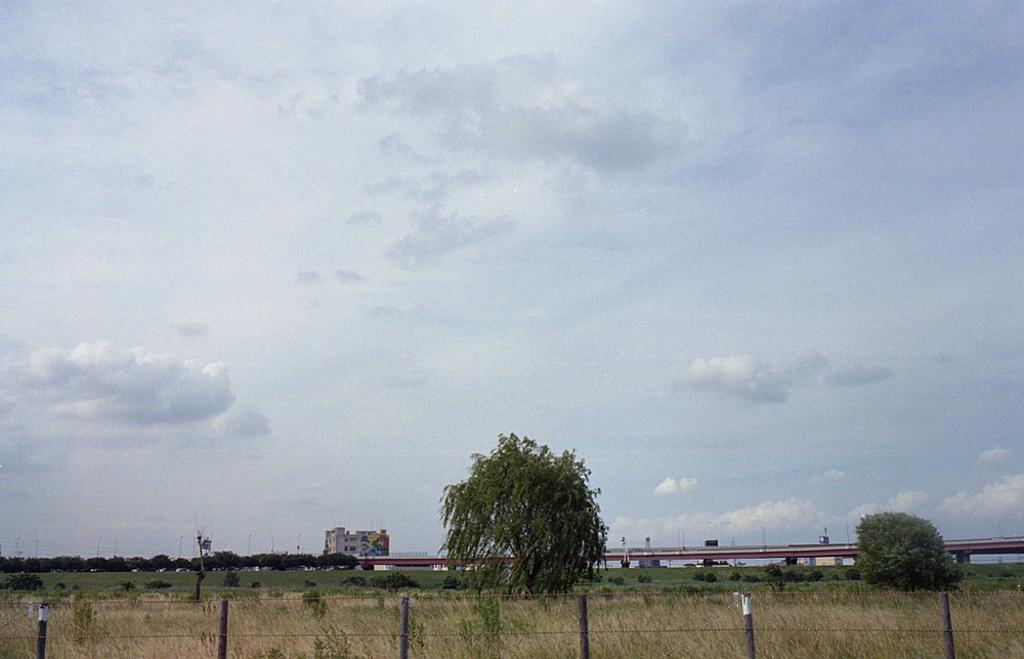In one or two sentences, can you explain what this image depicts? This image is taken outdoors. At the top of the image there is the sky with clouds. At the bottom of the image there is grass on the ground and there is a fence. In the background there is a bridge. There are a few buildings. There are a few poles. There are many trees. In the middle of the image there are a few plants. There are two trees. 